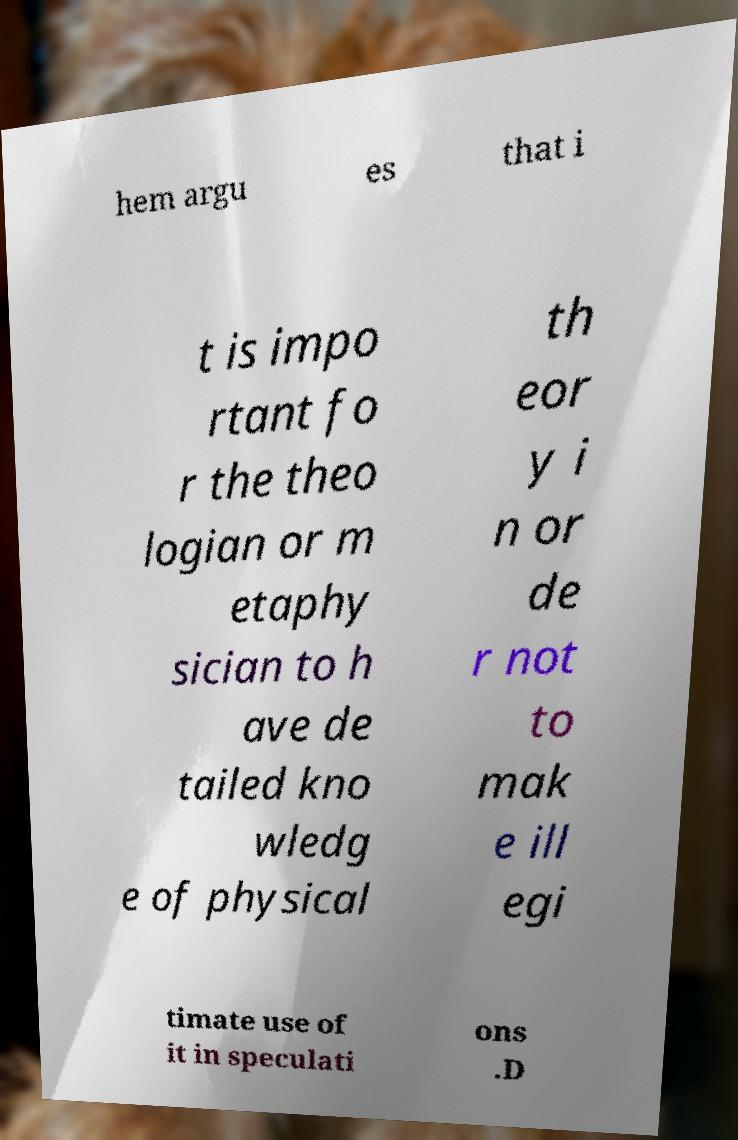Could you extract and type out the text from this image? hem argu es that i t is impo rtant fo r the theo logian or m etaphy sician to h ave de tailed kno wledg e of physical th eor y i n or de r not to mak e ill egi timate use of it in speculati ons .D 